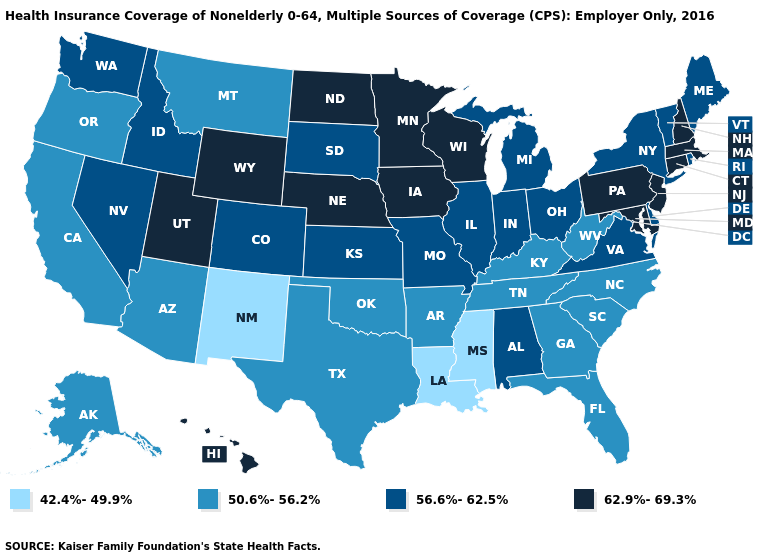Name the states that have a value in the range 50.6%-56.2%?
Answer briefly. Alaska, Arizona, Arkansas, California, Florida, Georgia, Kentucky, Montana, North Carolina, Oklahoma, Oregon, South Carolina, Tennessee, Texas, West Virginia. What is the value of Oklahoma?
Concise answer only. 50.6%-56.2%. Among the states that border North Dakota , which have the lowest value?
Be succinct. Montana. Does Utah have the lowest value in the West?
Short answer required. No. Which states hav the highest value in the MidWest?
Answer briefly. Iowa, Minnesota, Nebraska, North Dakota, Wisconsin. What is the highest value in the USA?
Be succinct. 62.9%-69.3%. Which states have the lowest value in the MidWest?
Answer briefly. Illinois, Indiana, Kansas, Michigan, Missouri, Ohio, South Dakota. Name the states that have a value in the range 50.6%-56.2%?
Concise answer only. Alaska, Arizona, Arkansas, California, Florida, Georgia, Kentucky, Montana, North Carolina, Oklahoma, Oregon, South Carolina, Tennessee, Texas, West Virginia. Name the states that have a value in the range 62.9%-69.3%?
Short answer required. Connecticut, Hawaii, Iowa, Maryland, Massachusetts, Minnesota, Nebraska, New Hampshire, New Jersey, North Dakota, Pennsylvania, Utah, Wisconsin, Wyoming. What is the value of New Jersey?
Keep it brief. 62.9%-69.3%. Name the states that have a value in the range 62.9%-69.3%?
Short answer required. Connecticut, Hawaii, Iowa, Maryland, Massachusetts, Minnesota, Nebraska, New Hampshire, New Jersey, North Dakota, Pennsylvania, Utah, Wisconsin, Wyoming. What is the highest value in the West ?
Write a very short answer. 62.9%-69.3%. Does New Mexico have the lowest value in the USA?
Write a very short answer. Yes. Name the states that have a value in the range 62.9%-69.3%?
Keep it brief. Connecticut, Hawaii, Iowa, Maryland, Massachusetts, Minnesota, Nebraska, New Hampshire, New Jersey, North Dakota, Pennsylvania, Utah, Wisconsin, Wyoming. What is the value of New Hampshire?
Be succinct. 62.9%-69.3%. 